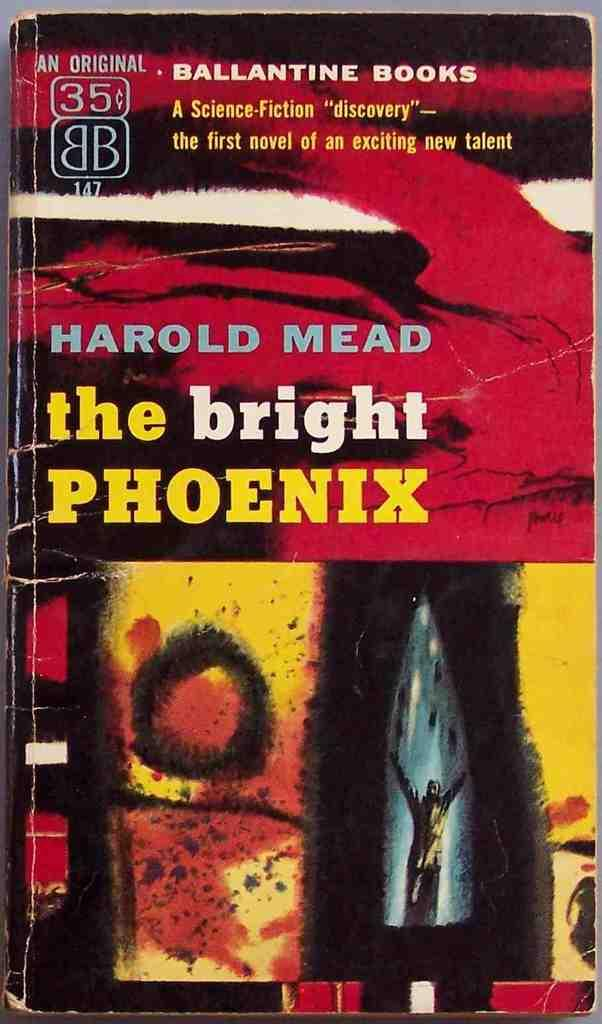Provide a one-sentence caption for the provided image. a book by HAROLD MEAD entitled the bright PHOENIX from BALLANTINE BOOKS. 